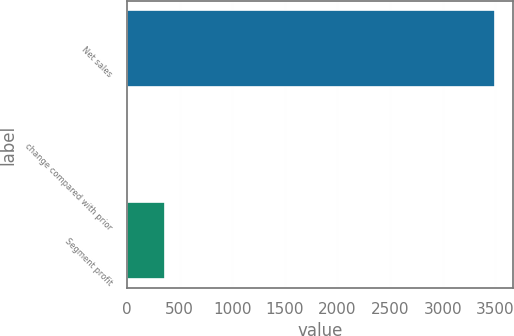Convert chart to OTSL. <chart><loc_0><loc_0><loc_500><loc_500><bar_chart><fcel>Net sales<fcel>change compared with prior<fcel>Segment profit<nl><fcel>3497<fcel>10<fcel>358.7<nl></chart> 